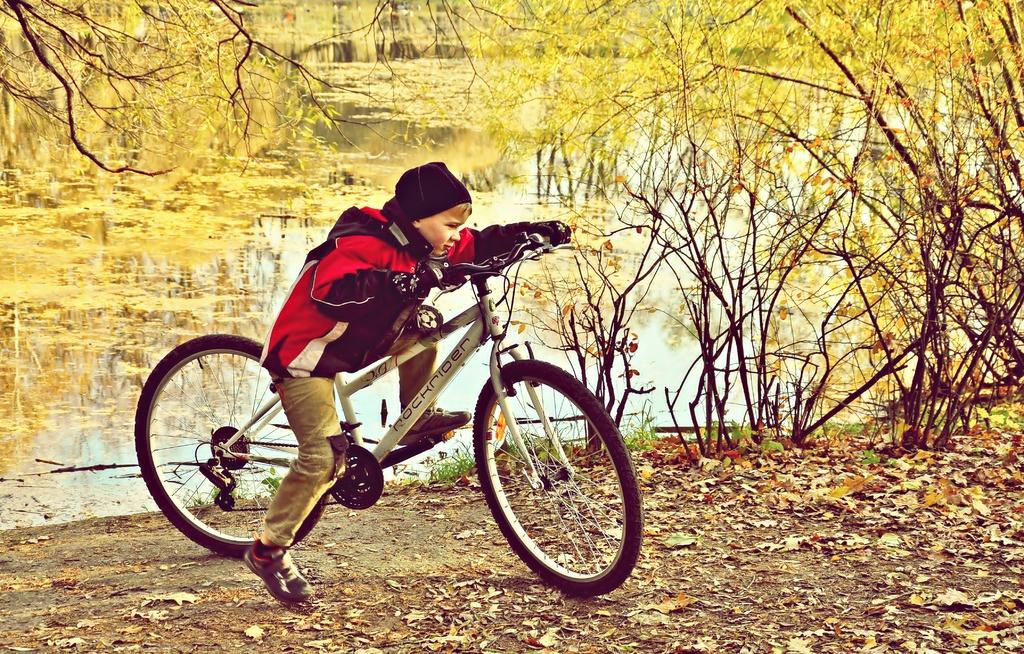What is the main subject of the image? There is a person riding a bicycle in the image. What can be seen in the background of the image? There are trees and water visible in the image. What type of polish is the person applying to the bicycle in the image? There is no indication in the image that the person is applying any polish to the bicycle. 